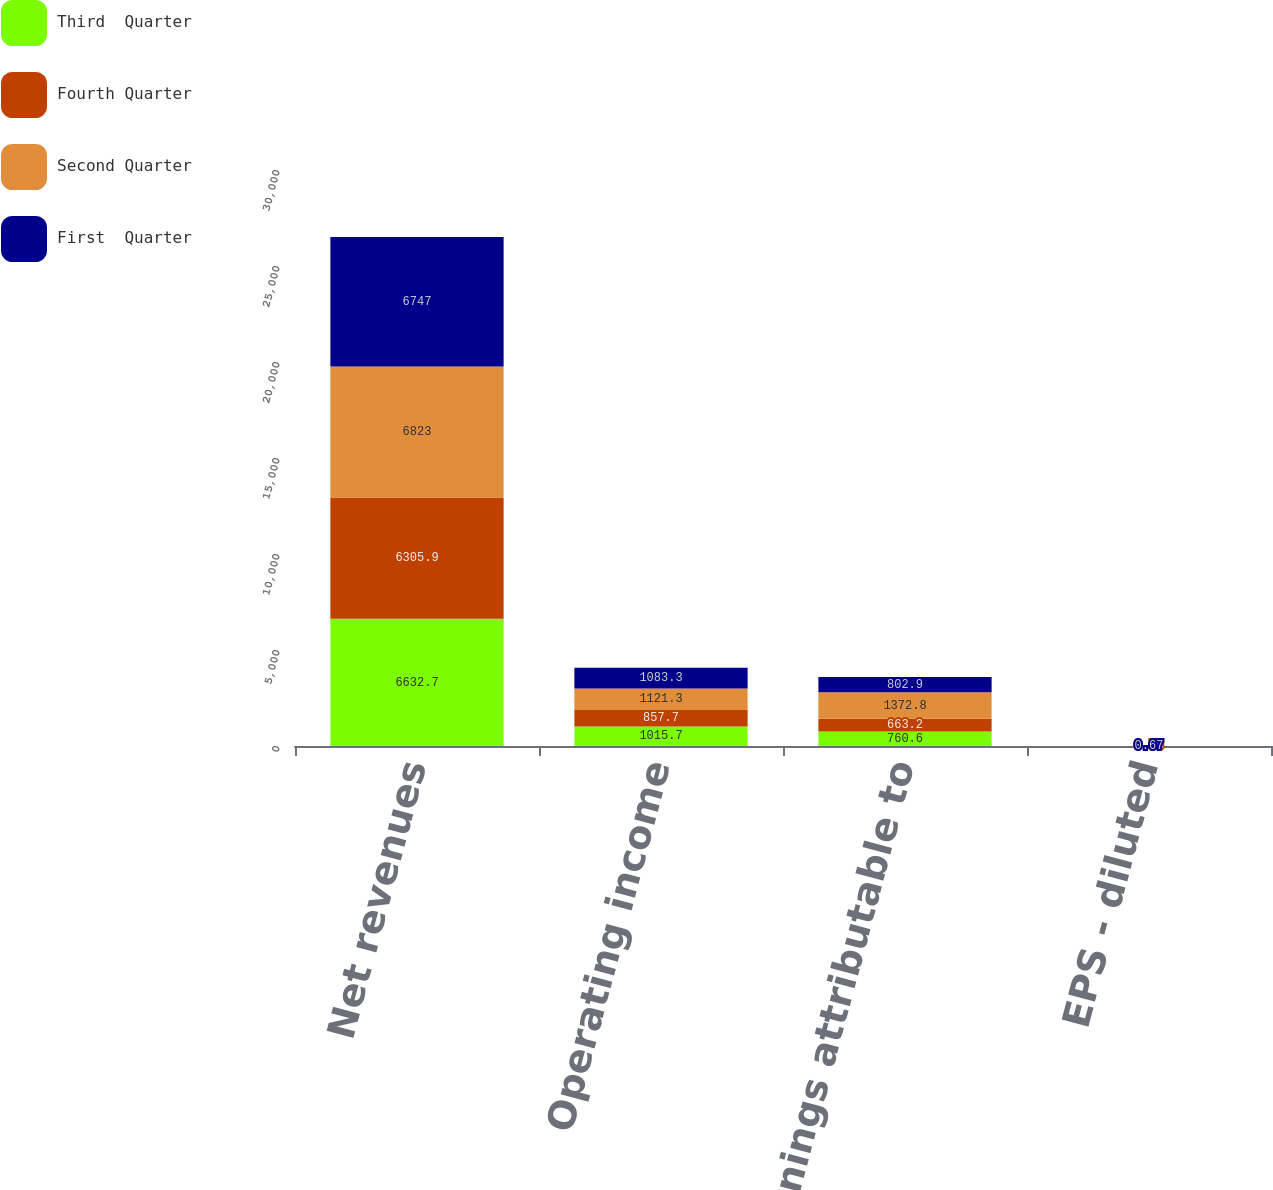Convert chart to OTSL. <chart><loc_0><loc_0><loc_500><loc_500><stacked_bar_chart><ecel><fcel>Net revenues<fcel>Operating income<fcel>Net earnings attributable to<fcel>EPS - diluted<nl><fcel>Third  Quarter<fcel>6632.7<fcel>1015.7<fcel>760.6<fcel>0.61<nl><fcel>Fourth Quarter<fcel>6305.9<fcel>857.7<fcel>663.2<fcel>0.53<nl><fcel>Second Quarter<fcel>6823<fcel>1121.3<fcel>1372.8<fcel>1.12<nl><fcel>First  Quarter<fcel>6747<fcel>1083.3<fcel>802.9<fcel>0.67<nl></chart> 